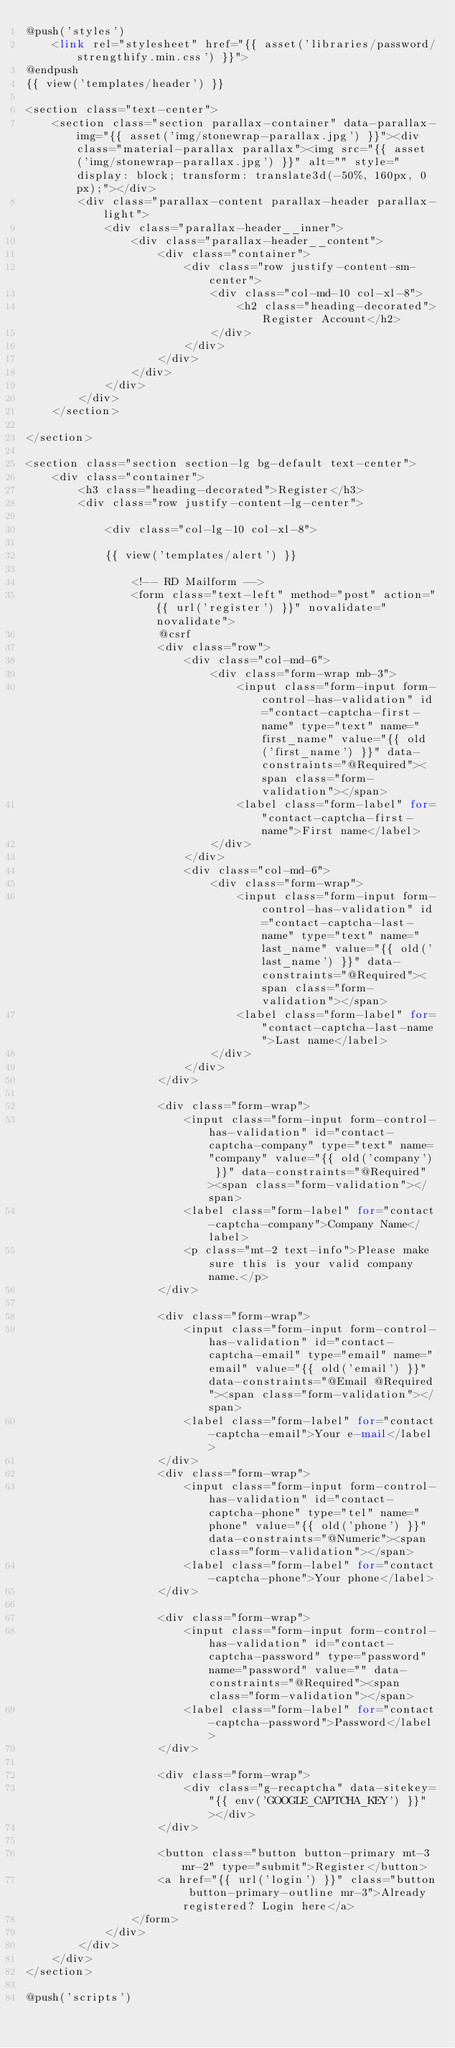Convert code to text. <code><loc_0><loc_0><loc_500><loc_500><_PHP_>@push('styles')
    <link rel="stylesheet" href="{{ asset('libraries/password/strengthify.min.css') }}">
@endpush
{{ view('templates/header') }}

<section class="text-center">
    <section class="section parallax-container" data-parallax-img="{{ asset('img/stonewrap-parallax.jpg') }}"><div class="material-parallax parallax"><img src="{{ asset('img/stonewrap-parallax.jpg') }}" alt="" style="display: block; transform: translate3d(-50%, 160px, 0px);"></div>
        <div class="parallax-content parallax-header parallax-light">
            <div class="parallax-header__inner">
                <div class="parallax-header__content">
                    <div class="container">
                        <div class="row justify-content-sm-center">
                            <div class="col-md-10 col-xl-8">
                                <h2 class="heading-decorated">Register Account</h2>
                            </div>
                        </div>
                    </div>
                </div>
            </div>
        </div>
    </section>

</section>

<section class="section section-lg bg-default text-center">
    <div class="container">
        <h3 class="heading-decorated">Register</h3>
        <div class="row justify-content-lg-center">

            <div class="col-lg-10 col-xl-8">

            {{ view('templates/alert') }}

                <!-- RD Mailform -->
                <form class="text-left" method="post" action="{{ url('register') }}" novalidate="novalidate">
                    @csrf
                    <div class="row">
                        <div class="col-md-6">
                            <div class="form-wrap mb-3">
                                <input class="form-input form-control-has-validation" id="contact-captcha-first-name" type="text" name="first_name" value="{{ old('first_name') }}" data-constraints="@Required"><span class="form-validation"></span>
                                <label class="form-label" for="contact-captcha-first-name">First name</label>
                            </div>
                        </div>
                        <div class="col-md-6">
                            <div class="form-wrap">
                                <input class="form-input form-control-has-validation" id="contact-captcha-last-name" type="text" name="last_name" value="{{ old('last_name') }}" data-constraints="@Required"><span class="form-validation"></span>
                                <label class="form-label" for="contact-captcha-last-name">Last name</label>
                            </div>
                        </div>
                    </div>

                    <div class="form-wrap">
                        <input class="form-input form-control-has-validation" id="contact-captcha-company" type="text" name="company" value="{{ old('company') }}" data-constraints="@Required"><span class="form-validation"></span>
                        <label class="form-label" for="contact-captcha-company">Company Name</label>
                        <p class="mt-2 text-info">Please make sure this is your valid company name.</p>
                    </div>

                    <div class="form-wrap">
                        <input class="form-input form-control-has-validation" id="contact-captcha-email" type="email" name="email" value="{{ old('email') }}" data-constraints="@Email @Required"><span class="form-validation"></span>
                        <label class="form-label" for="contact-captcha-email">Your e-mail</label>
                    </div>
                    <div class="form-wrap">
                        <input class="form-input form-control-has-validation" id="contact-captcha-phone" type="tel" name="phone" value="{{ old('phone') }}" data-constraints="@Numeric"><span class="form-validation"></span>
                        <label class="form-label" for="contact-captcha-phone">Your phone</label>
                    </div>

                    <div class="form-wrap">
                        <input class="form-input form-control-has-validation" id="contact-captcha-password" type="password" name="password" value="" data-constraints="@Required"><span class="form-validation"></span>
                        <label class="form-label" for="contact-captcha-password">Password</label>
                    </div>

                    <div class="form-wrap">
                        <div class="g-recaptcha" data-sitekey="{{ env('GOOGLE_CAPTCHA_KEY') }}"></div>
                    </div>

                    <button class="button button-primary mt-3 mr-2" type="submit">Register</button>
                    <a href="{{ url('login') }}" class="button button-primary-outline mr-3">Already registered? Login here</a>
                </form>
            </div>
        </div>
    </div>
</section>

@push('scripts')</code> 